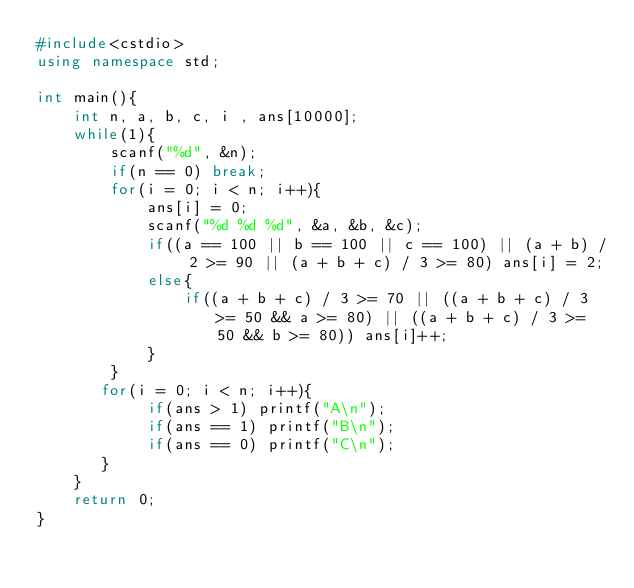Convert code to text. <code><loc_0><loc_0><loc_500><loc_500><_C++_>#include<cstdio>
using namespace std; 

int main(){
    int n, a, b, c, i , ans[10000];
    while(1){
        scanf("%d", &n);
        if(n == 0) break;
        for(i = 0; i < n; i++){
            ans[i] = 0;
            scanf("%d %d %d", &a, &b, &c);
            if((a == 100 || b == 100 || c == 100) || (a + b) / 2 >= 90 || (a + b + c) / 3 >= 80) ans[i] = 2;
            else{
                if((a + b + c) / 3 >= 70 || ((a + b + c) / 3 >= 50 && a >= 80) || ((a + b + c) / 3 >= 50 && b >= 80)) ans[i]++;
            }
        }
       for(i = 0; i < n; i++){
            if(ans > 1) printf("A\n");
            if(ans == 1) printf("B\n");
            if(ans == 0) printf("C\n");
       }
    }
    return 0;
}</code> 